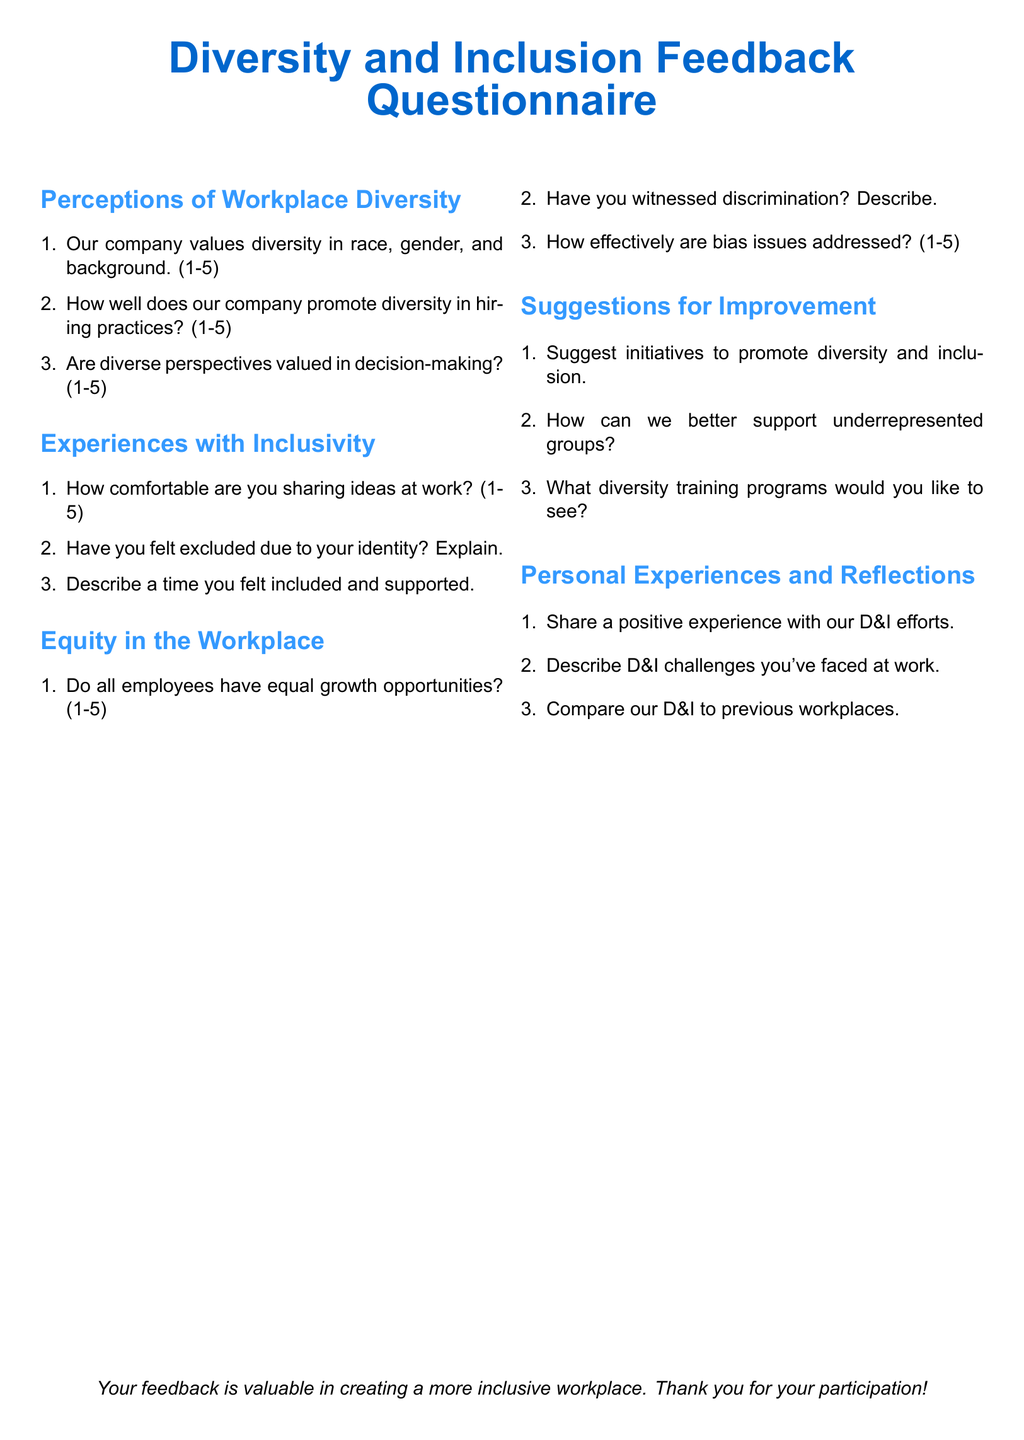What is the title of the document? The title is prominently displayed at the top of the document.
Answer: Diversity and Inclusion Feedback Questionnaire How many sections are there in the questionnaire? The document consists of multiple sections, including perceptions, experiences, equity, suggestions, and personal reflections.
Answer: Five What scale is used for the rating questions? The document specifies a scale for rating perceptions and experiences, indicating a range.
Answer: 1-5 What is asked regarding personal experiences? This section focuses on the individual's experiences related to diversity and inclusion in the workplace.
Answer: Positive experiences and challenges What color is used for the header? The header color is part of the document design, giving a distinctive look.
Answer: RGB(0,102,204) 